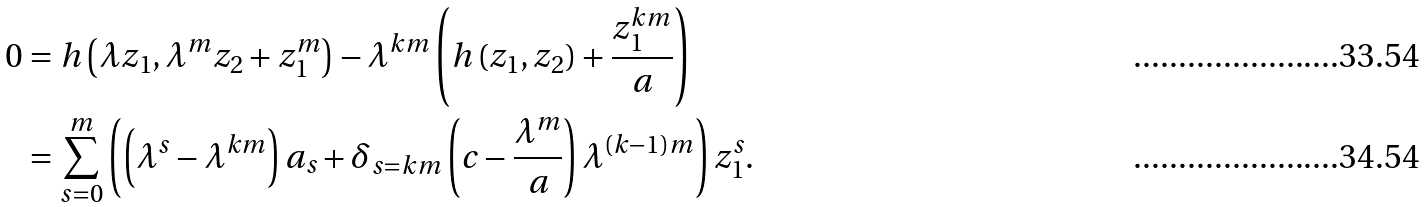<formula> <loc_0><loc_0><loc_500><loc_500>0 & = h \left ( \lambda z _ { 1 } , \lambda ^ { m } z _ { 2 } + z _ { 1 } ^ { m } \right ) - \lambda ^ { k m } \left ( h \left ( z _ { 1 } , z _ { 2 } \right ) + \frac { z _ { 1 } ^ { k m } } { a } \right ) \\ & = \sum _ { s = 0 } ^ { m } \left ( \left ( \lambda ^ { s } - \lambda ^ { k m } \right ) a _ { s } + \delta _ { s = k m } \left ( c - \frac { \lambda ^ { m } } { a } \right ) \lambda ^ { ( k - 1 ) m } \right ) z _ { 1 } ^ { s } .</formula> 